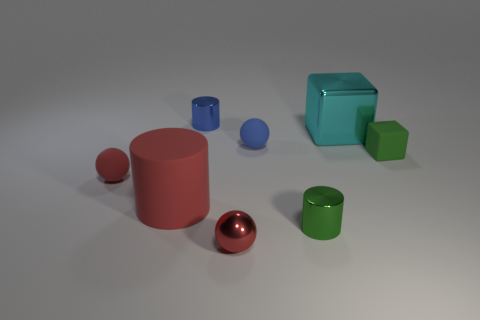There is a blue rubber thing; is it the same shape as the metal object that is behind the cyan metal thing?
Make the answer very short. No. There is a shiny cylinder on the right side of the blue cylinder; is it the same size as the large cube?
Ensure brevity in your answer.  No. What is the shape of the blue shiny object that is the same size as the green metal thing?
Your answer should be compact. Cylinder. Is the big shiny object the same shape as the small blue shiny object?
Provide a succinct answer. No. How many blue objects are the same shape as the small red matte object?
Make the answer very short. 1. How many small red objects are in front of the big cylinder?
Provide a short and direct response. 1. There is a small rubber thing left of the big red cylinder; is its color the same as the tiny cube?
Your answer should be very brief. No. How many objects have the same size as the cyan cube?
Keep it short and to the point. 1. There is a small blue thing that is the same material as the large red cylinder; what shape is it?
Make the answer very short. Sphere. Are there any other big cylinders that have the same color as the large cylinder?
Make the answer very short. No. 